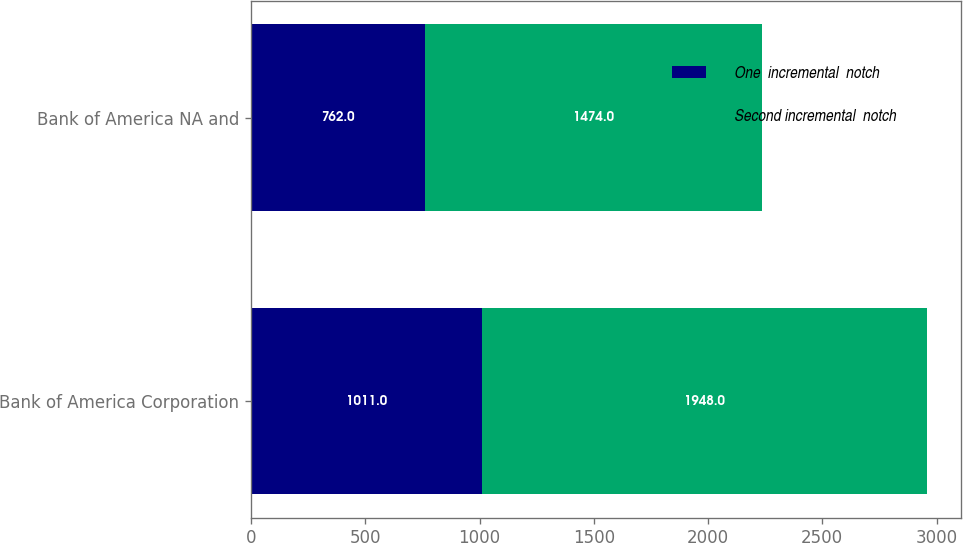<chart> <loc_0><loc_0><loc_500><loc_500><stacked_bar_chart><ecel><fcel>Bank of America Corporation<fcel>Bank of America NA and<nl><fcel>One  incremental  notch<fcel>1011<fcel>762<nl><fcel>Second incremental  notch<fcel>1948<fcel>1474<nl></chart> 